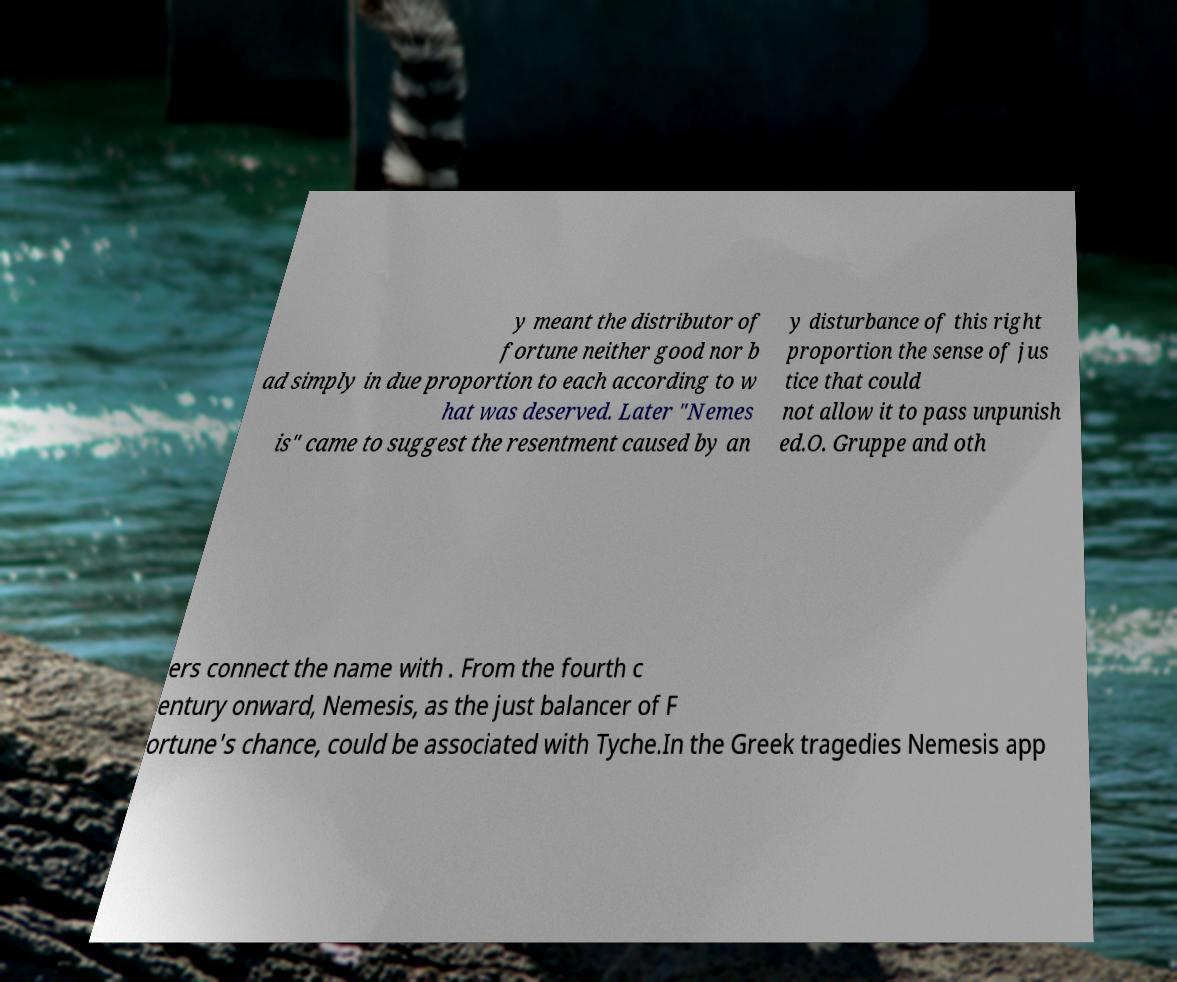Could you assist in decoding the text presented in this image and type it out clearly? y meant the distributor of fortune neither good nor b ad simply in due proportion to each according to w hat was deserved. Later "Nemes is" came to suggest the resentment caused by an y disturbance of this right proportion the sense of jus tice that could not allow it to pass unpunish ed.O. Gruppe and oth ers connect the name with . From the fourth c entury onward, Nemesis, as the just balancer of F ortune's chance, could be associated with Tyche.In the Greek tragedies Nemesis app 